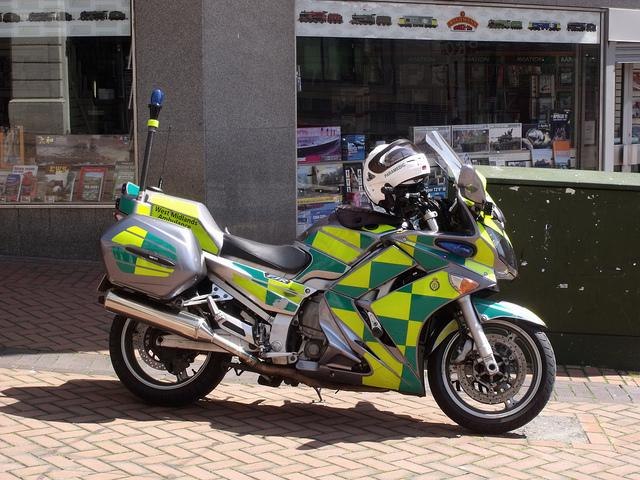The markings on the fairings of the motorcycle indicate that it belongs to which type of public organization? Please explain your reasoning. public health. The motorcycle says ambulance. 